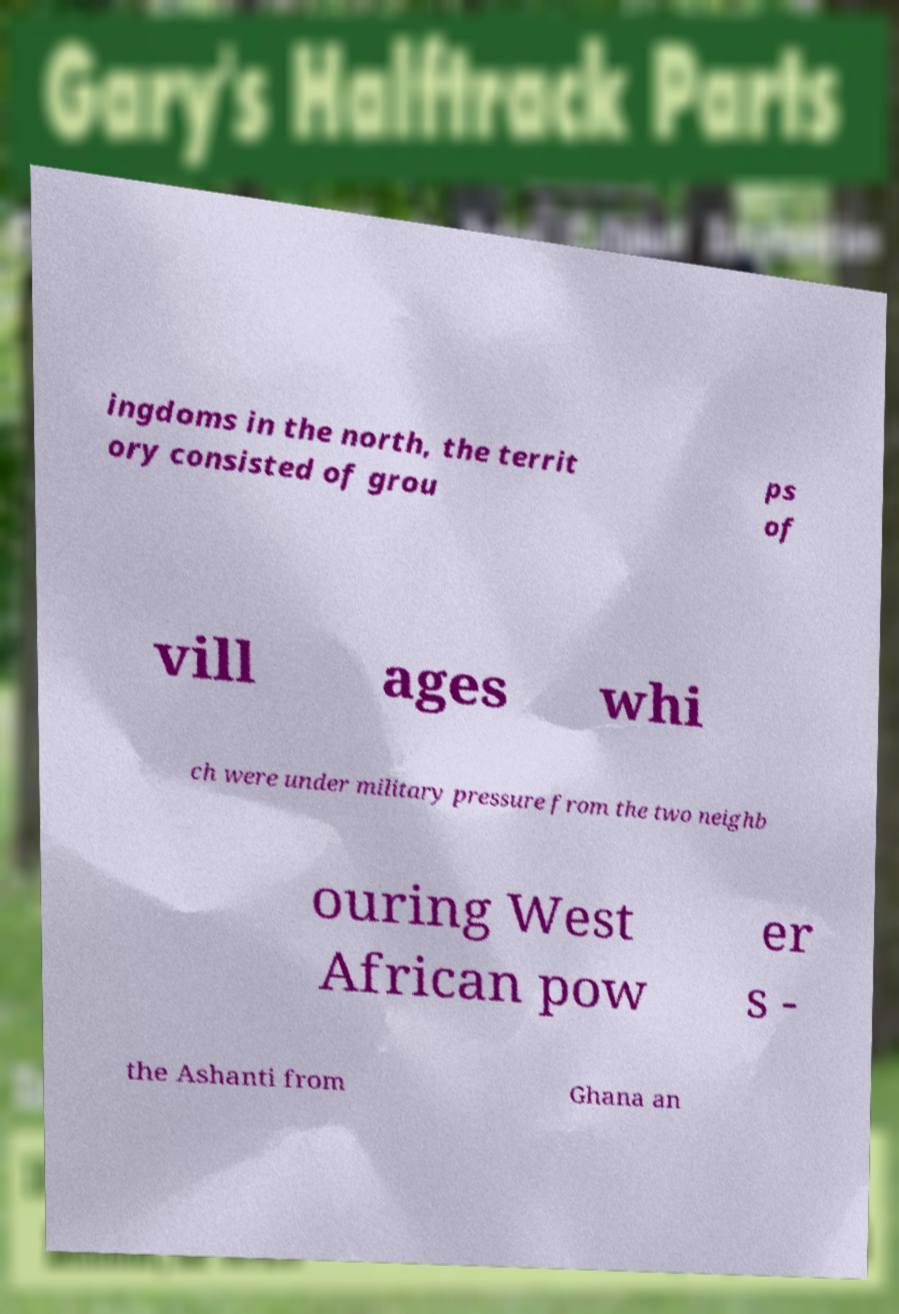I need the written content from this picture converted into text. Can you do that? ingdoms in the north, the territ ory consisted of grou ps of vill ages whi ch were under military pressure from the two neighb ouring West African pow er s - the Ashanti from Ghana an 